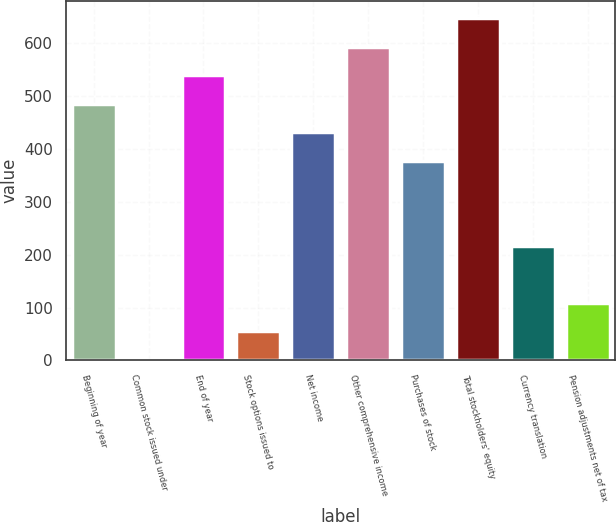<chart> <loc_0><loc_0><loc_500><loc_500><bar_chart><fcel>Beginning of year<fcel>Common stock issued under<fcel>End of year<fcel>Stock options issued to<fcel>Net income<fcel>Other comprehensive income<fcel>Purchases of stock<fcel>Total stockholders' equity<fcel>Currency translation<fcel>Pension adjustments net of tax<nl><fcel>485.55<fcel>0.9<fcel>539.4<fcel>54.75<fcel>431.7<fcel>593.25<fcel>377.85<fcel>647.1<fcel>216.3<fcel>108.6<nl></chart> 